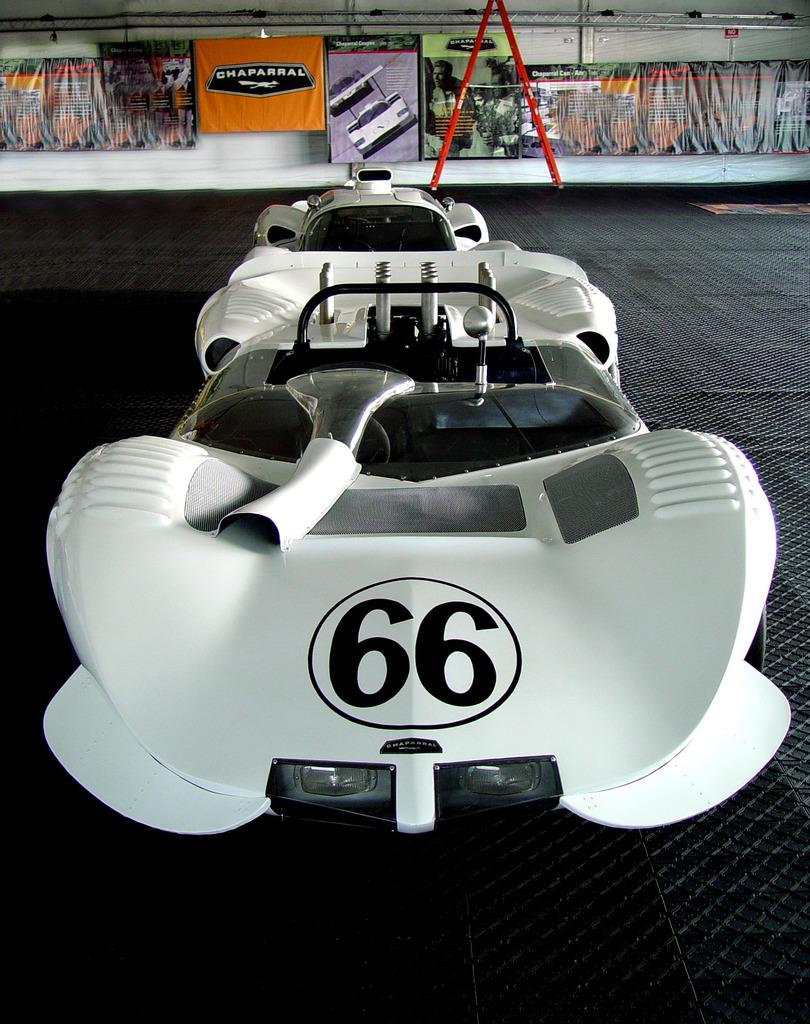What type of vehicles are in the image? There are two white color vehicles in the image. What is the color of the floor where the vehicles are placed? The vehicles are on a black color floor. What can be seen in the background of the image? There are posters and a white color wall in the background of the image. Are there any fairies flying around the vehicles in the image? No, there are no fairies present in the image. What type of sail can be seen on the vehicles in the image? The vehicles in the image are not sailing vessels, so there is no sail present. 